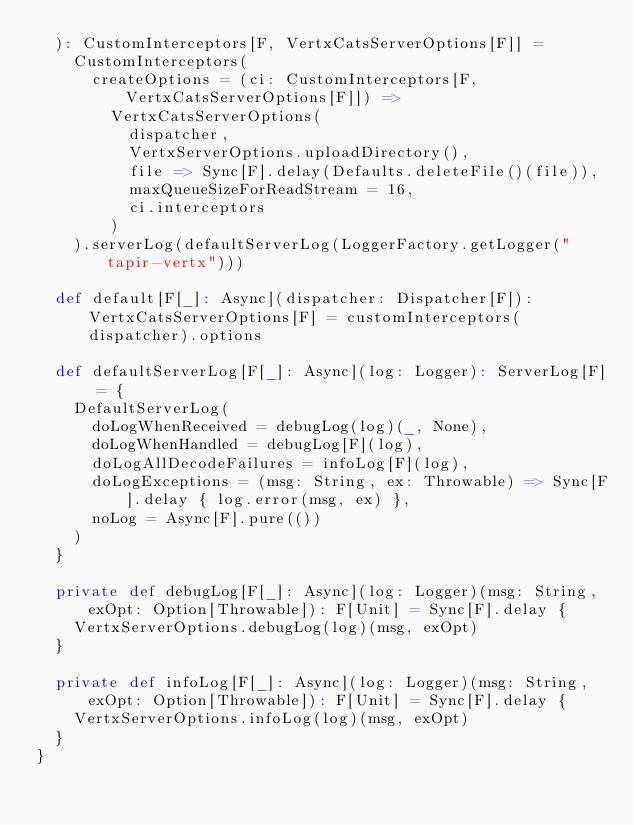Convert code to text. <code><loc_0><loc_0><loc_500><loc_500><_Scala_>  ): CustomInterceptors[F, VertxCatsServerOptions[F]] =
    CustomInterceptors(
      createOptions = (ci: CustomInterceptors[F, VertxCatsServerOptions[F]]) =>
        VertxCatsServerOptions(
          dispatcher,
          VertxServerOptions.uploadDirectory(),
          file => Sync[F].delay(Defaults.deleteFile()(file)),
          maxQueueSizeForReadStream = 16,
          ci.interceptors
        )
    ).serverLog(defaultServerLog(LoggerFactory.getLogger("tapir-vertx")))

  def default[F[_]: Async](dispatcher: Dispatcher[F]): VertxCatsServerOptions[F] = customInterceptors(dispatcher).options

  def defaultServerLog[F[_]: Async](log: Logger): ServerLog[F] = {
    DefaultServerLog(
      doLogWhenReceived = debugLog(log)(_, None),
      doLogWhenHandled = debugLog[F](log),
      doLogAllDecodeFailures = infoLog[F](log),
      doLogExceptions = (msg: String, ex: Throwable) => Sync[F].delay { log.error(msg, ex) },
      noLog = Async[F].pure(())
    )
  }

  private def debugLog[F[_]: Async](log: Logger)(msg: String, exOpt: Option[Throwable]): F[Unit] = Sync[F].delay {
    VertxServerOptions.debugLog(log)(msg, exOpt)
  }

  private def infoLog[F[_]: Async](log: Logger)(msg: String, exOpt: Option[Throwable]): F[Unit] = Sync[F].delay {
    VertxServerOptions.infoLog(log)(msg, exOpt)
  }
}
</code> 